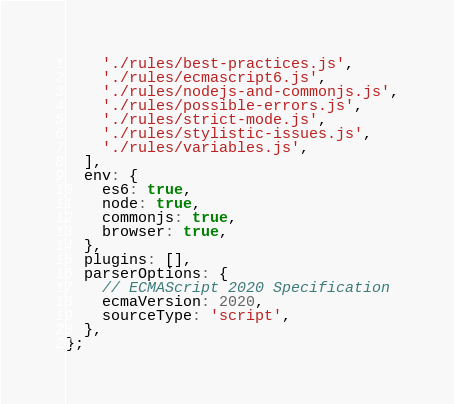Convert code to text. <code><loc_0><loc_0><loc_500><loc_500><_JavaScript_>    './rules/best-practices.js',
    './rules/ecmascript6.js',
    './rules/nodejs-and-commonjs.js',
    './rules/possible-errors.js',
    './rules/strict-mode.js',
    './rules/stylistic-issues.js',
    './rules/variables.js',
  ],
  env: {
    es6: true,
    node: true,
    commonjs: true,
    browser: true,
  },
  plugins: [],
  parserOptions: {
    // ECMAScript 2020 Specification
    ecmaVersion: 2020,
    sourceType: 'script',
  },
};
</code> 